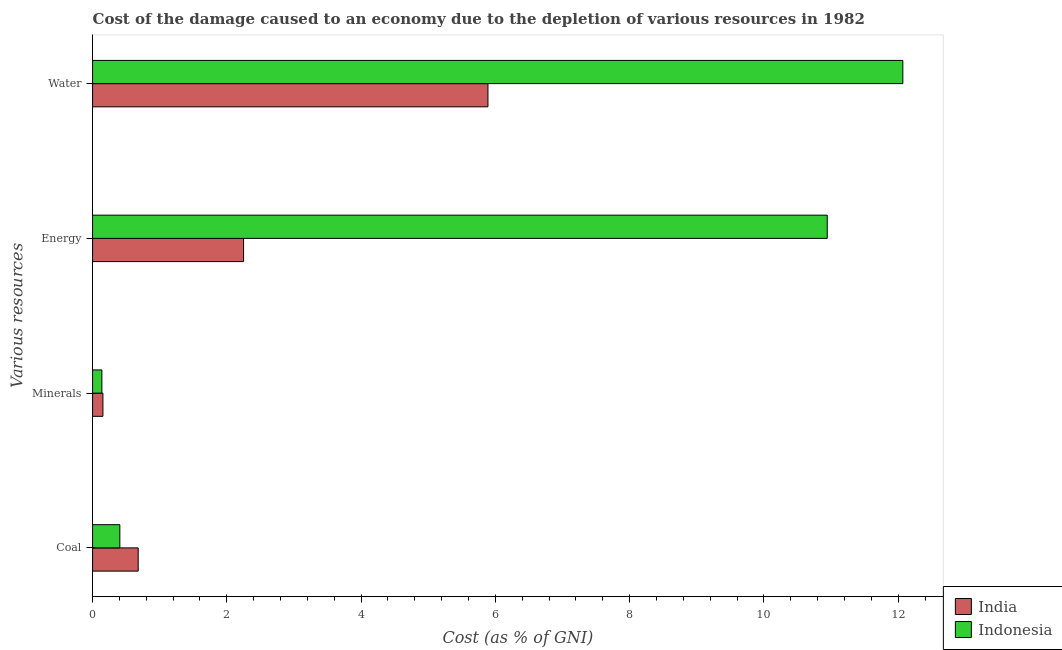How many different coloured bars are there?
Make the answer very short. 2. How many groups of bars are there?
Your response must be concise. 4. Are the number of bars on each tick of the Y-axis equal?
Your answer should be compact. Yes. How many bars are there on the 4th tick from the bottom?
Give a very brief answer. 2. What is the label of the 2nd group of bars from the top?
Keep it short and to the point. Energy. What is the cost of damage due to depletion of water in Indonesia?
Offer a very short reply. 12.07. Across all countries, what is the maximum cost of damage due to depletion of water?
Provide a succinct answer. 12.07. Across all countries, what is the minimum cost of damage due to depletion of coal?
Offer a terse response. 0.41. In which country was the cost of damage due to depletion of coal maximum?
Offer a terse response. India. What is the total cost of damage due to depletion of minerals in the graph?
Your answer should be compact. 0.29. What is the difference between the cost of damage due to depletion of water in India and that in Indonesia?
Provide a short and direct response. -6.18. What is the difference between the cost of damage due to depletion of water in Indonesia and the cost of damage due to depletion of energy in India?
Offer a very short reply. 9.82. What is the average cost of damage due to depletion of water per country?
Your answer should be compact. 8.98. What is the difference between the cost of damage due to depletion of energy and cost of damage due to depletion of coal in India?
Your response must be concise. 1.57. What is the ratio of the cost of damage due to depletion of energy in India to that in Indonesia?
Your response must be concise. 0.21. What is the difference between the highest and the second highest cost of damage due to depletion of coal?
Your answer should be very brief. 0.27. What is the difference between the highest and the lowest cost of damage due to depletion of minerals?
Keep it short and to the point. 0.02. Is the sum of the cost of damage due to depletion of energy in India and Indonesia greater than the maximum cost of damage due to depletion of coal across all countries?
Provide a short and direct response. Yes. Is it the case that in every country, the sum of the cost of damage due to depletion of energy and cost of damage due to depletion of coal is greater than the sum of cost of damage due to depletion of minerals and cost of damage due to depletion of water?
Offer a terse response. No. What does the 2nd bar from the top in Water represents?
Your answer should be very brief. India. What does the 2nd bar from the bottom in Water represents?
Provide a short and direct response. Indonesia. Is it the case that in every country, the sum of the cost of damage due to depletion of coal and cost of damage due to depletion of minerals is greater than the cost of damage due to depletion of energy?
Give a very brief answer. No. How many bars are there?
Your answer should be very brief. 8. Are all the bars in the graph horizontal?
Provide a short and direct response. Yes. How many countries are there in the graph?
Make the answer very short. 2. What is the difference between two consecutive major ticks on the X-axis?
Your answer should be compact. 2. Does the graph contain any zero values?
Your response must be concise. No. Does the graph contain grids?
Offer a very short reply. No. Where does the legend appear in the graph?
Your answer should be compact. Bottom right. What is the title of the graph?
Keep it short and to the point. Cost of the damage caused to an economy due to the depletion of various resources in 1982 . What is the label or title of the X-axis?
Your answer should be compact. Cost (as % of GNI). What is the label or title of the Y-axis?
Your answer should be very brief. Various resources. What is the Cost (as % of GNI) of India in Coal?
Give a very brief answer. 0.68. What is the Cost (as % of GNI) of Indonesia in Coal?
Offer a terse response. 0.41. What is the Cost (as % of GNI) of India in Minerals?
Offer a very short reply. 0.15. What is the Cost (as % of GNI) of Indonesia in Minerals?
Your answer should be very brief. 0.14. What is the Cost (as % of GNI) of India in Energy?
Give a very brief answer. 2.25. What is the Cost (as % of GNI) in Indonesia in Energy?
Provide a succinct answer. 10.94. What is the Cost (as % of GNI) of India in Water?
Your answer should be compact. 5.89. What is the Cost (as % of GNI) of Indonesia in Water?
Offer a very short reply. 12.07. Across all Various resources, what is the maximum Cost (as % of GNI) in India?
Your response must be concise. 5.89. Across all Various resources, what is the maximum Cost (as % of GNI) in Indonesia?
Your answer should be very brief. 12.07. Across all Various resources, what is the minimum Cost (as % of GNI) in India?
Make the answer very short. 0.15. Across all Various resources, what is the minimum Cost (as % of GNI) in Indonesia?
Provide a succinct answer. 0.14. What is the total Cost (as % of GNI) of India in the graph?
Give a very brief answer. 8.97. What is the total Cost (as % of GNI) in Indonesia in the graph?
Offer a terse response. 23.56. What is the difference between the Cost (as % of GNI) of India in Coal and that in Minerals?
Ensure brevity in your answer.  0.53. What is the difference between the Cost (as % of GNI) of Indonesia in Coal and that in Minerals?
Provide a short and direct response. 0.27. What is the difference between the Cost (as % of GNI) of India in Coal and that in Energy?
Offer a very short reply. -1.57. What is the difference between the Cost (as % of GNI) of Indonesia in Coal and that in Energy?
Your answer should be compact. -10.54. What is the difference between the Cost (as % of GNI) of India in Coal and that in Water?
Your answer should be compact. -5.21. What is the difference between the Cost (as % of GNI) of Indonesia in Coal and that in Water?
Offer a terse response. -11.66. What is the difference between the Cost (as % of GNI) of India in Minerals and that in Energy?
Offer a very short reply. -2.09. What is the difference between the Cost (as % of GNI) in Indonesia in Minerals and that in Energy?
Provide a succinct answer. -10.8. What is the difference between the Cost (as % of GNI) in India in Minerals and that in Water?
Your response must be concise. -5.74. What is the difference between the Cost (as % of GNI) in Indonesia in Minerals and that in Water?
Your answer should be compact. -11.93. What is the difference between the Cost (as % of GNI) of India in Energy and that in Water?
Provide a short and direct response. -3.64. What is the difference between the Cost (as % of GNI) of Indonesia in Energy and that in Water?
Ensure brevity in your answer.  -1.13. What is the difference between the Cost (as % of GNI) of India in Coal and the Cost (as % of GNI) of Indonesia in Minerals?
Offer a terse response. 0.54. What is the difference between the Cost (as % of GNI) of India in Coal and the Cost (as % of GNI) of Indonesia in Energy?
Offer a very short reply. -10.26. What is the difference between the Cost (as % of GNI) of India in Coal and the Cost (as % of GNI) of Indonesia in Water?
Offer a terse response. -11.39. What is the difference between the Cost (as % of GNI) in India in Minerals and the Cost (as % of GNI) in Indonesia in Energy?
Offer a terse response. -10.79. What is the difference between the Cost (as % of GNI) of India in Minerals and the Cost (as % of GNI) of Indonesia in Water?
Keep it short and to the point. -11.91. What is the difference between the Cost (as % of GNI) of India in Energy and the Cost (as % of GNI) of Indonesia in Water?
Give a very brief answer. -9.82. What is the average Cost (as % of GNI) of India per Various resources?
Make the answer very short. 2.24. What is the average Cost (as % of GNI) in Indonesia per Various resources?
Offer a very short reply. 5.89. What is the difference between the Cost (as % of GNI) of India and Cost (as % of GNI) of Indonesia in Coal?
Make the answer very short. 0.27. What is the difference between the Cost (as % of GNI) of India and Cost (as % of GNI) of Indonesia in Minerals?
Offer a very short reply. 0.02. What is the difference between the Cost (as % of GNI) of India and Cost (as % of GNI) of Indonesia in Energy?
Offer a very short reply. -8.69. What is the difference between the Cost (as % of GNI) of India and Cost (as % of GNI) of Indonesia in Water?
Your response must be concise. -6.18. What is the ratio of the Cost (as % of GNI) of India in Coal to that in Minerals?
Make the answer very short. 4.41. What is the ratio of the Cost (as % of GNI) of Indonesia in Coal to that in Minerals?
Keep it short and to the point. 2.93. What is the ratio of the Cost (as % of GNI) in India in Coal to that in Energy?
Provide a short and direct response. 0.3. What is the ratio of the Cost (as % of GNI) of Indonesia in Coal to that in Energy?
Offer a very short reply. 0.04. What is the ratio of the Cost (as % of GNI) of India in Coal to that in Water?
Your answer should be very brief. 0.12. What is the ratio of the Cost (as % of GNI) in Indonesia in Coal to that in Water?
Provide a short and direct response. 0.03. What is the ratio of the Cost (as % of GNI) of India in Minerals to that in Energy?
Your response must be concise. 0.07. What is the ratio of the Cost (as % of GNI) in Indonesia in Minerals to that in Energy?
Offer a very short reply. 0.01. What is the ratio of the Cost (as % of GNI) of India in Minerals to that in Water?
Ensure brevity in your answer.  0.03. What is the ratio of the Cost (as % of GNI) in Indonesia in Minerals to that in Water?
Offer a very short reply. 0.01. What is the ratio of the Cost (as % of GNI) in India in Energy to that in Water?
Ensure brevity in your answer.  0.38. What is the ratio of the Cost (as % of GNI) in Indonesia in Energy to that in Water?
Your answer should be very brief. 0.91. What is the difference between the highest and the second highest Cost (as % of GNI) in India?
Ensure brevity in your answer.  3.64. What is the difference between the highest and the second highest Cost (as % of GNI) of Indonesia?
Provide a short and direct response. 1.13. What is the difference between the highest and the lowest Cost (as % of GNI) in India?
Ensure brevity in your answer.  5.74. What is the difference between the highest and the lowest Cost (as % of GNI) in Indonesia?
Provide a short and direct response. 11.93. 